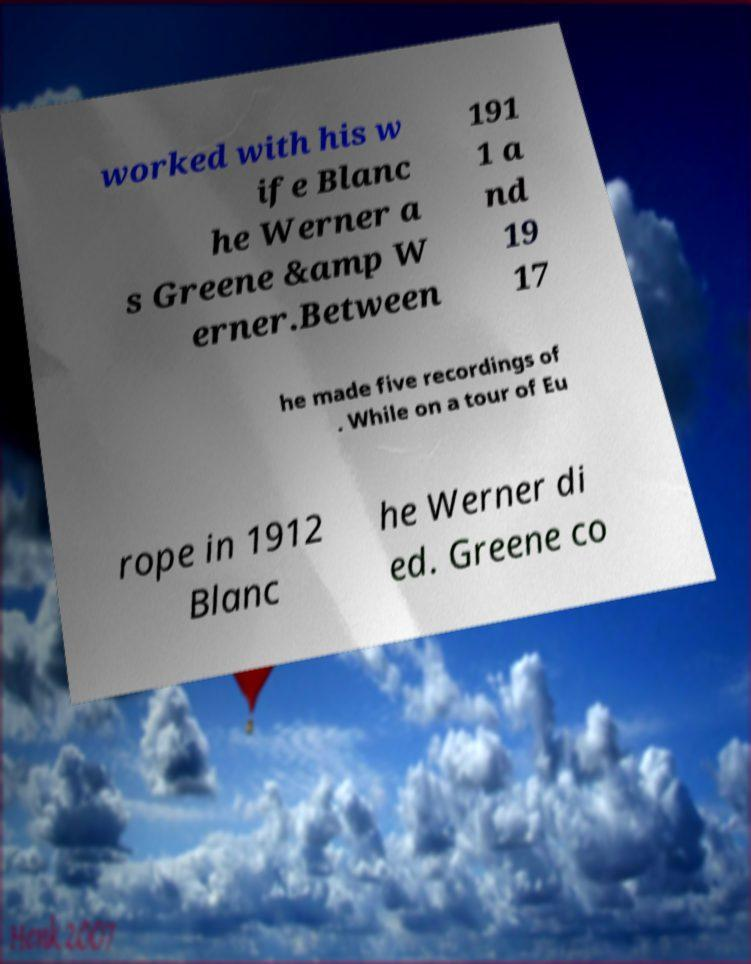I need the written content from this picture converted into text. Can you do that? worked with his w ife Blanc he Werner a s Greene &amp W erner.Between 191 1 a nd 19 17 he made five recordings of . While on a tour of Eu rope in 1912 Blanc he Werner di ed. Greene co 